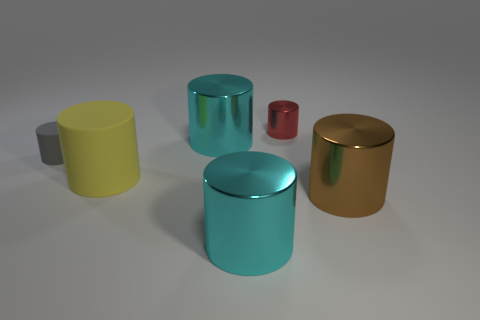Subtract all cyan cylinders. How many cylinders are left? 4 Subtract all cyan cylinders. How many cylinders are left? 4 Subtract all green cylinders. Subtract all gray spheres. How many cylinders are left? 6 Add 4 big metal things. How many objects exist? 10 Add 1 big matte things. How many big matte things are left? 2 Add 2 blue objects. How many blue objects exist? 2 Subtract 0 brown blocks. How many objects are left? 6 Subtract all big brown metal cylinders. Subtract all tiny rubber cylinders. How many objects are left? 4 